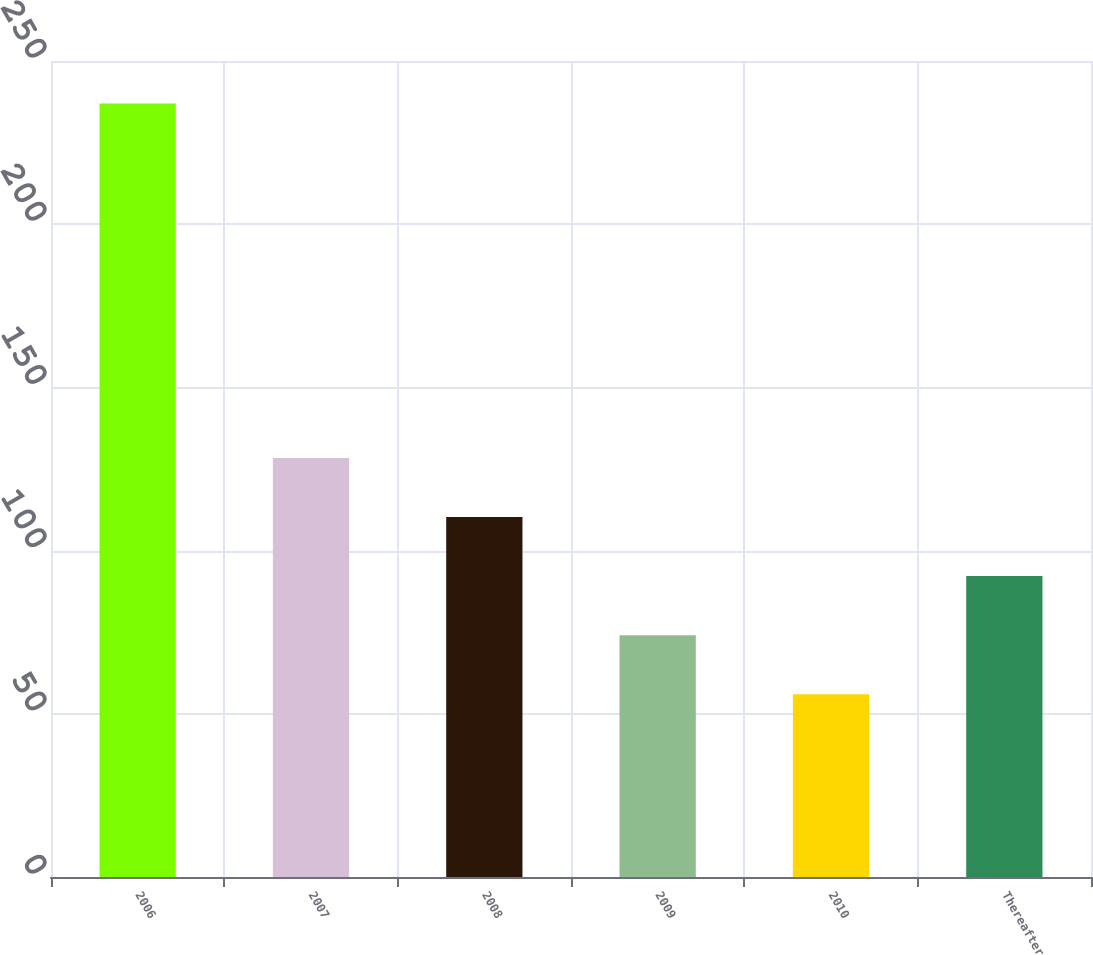<chart> <loc_0><loc_0><loc_500><loc_500><bar_chart><fcel>2006<fcel>2007<fcel>2008<fcel>2009<fcel>2010<fcel>Thereafter<nl><fcel>237<fcel>128.4<fcel>110.3<fcel>74.1<fcel>56<fcel>92.2<nl></chart> 